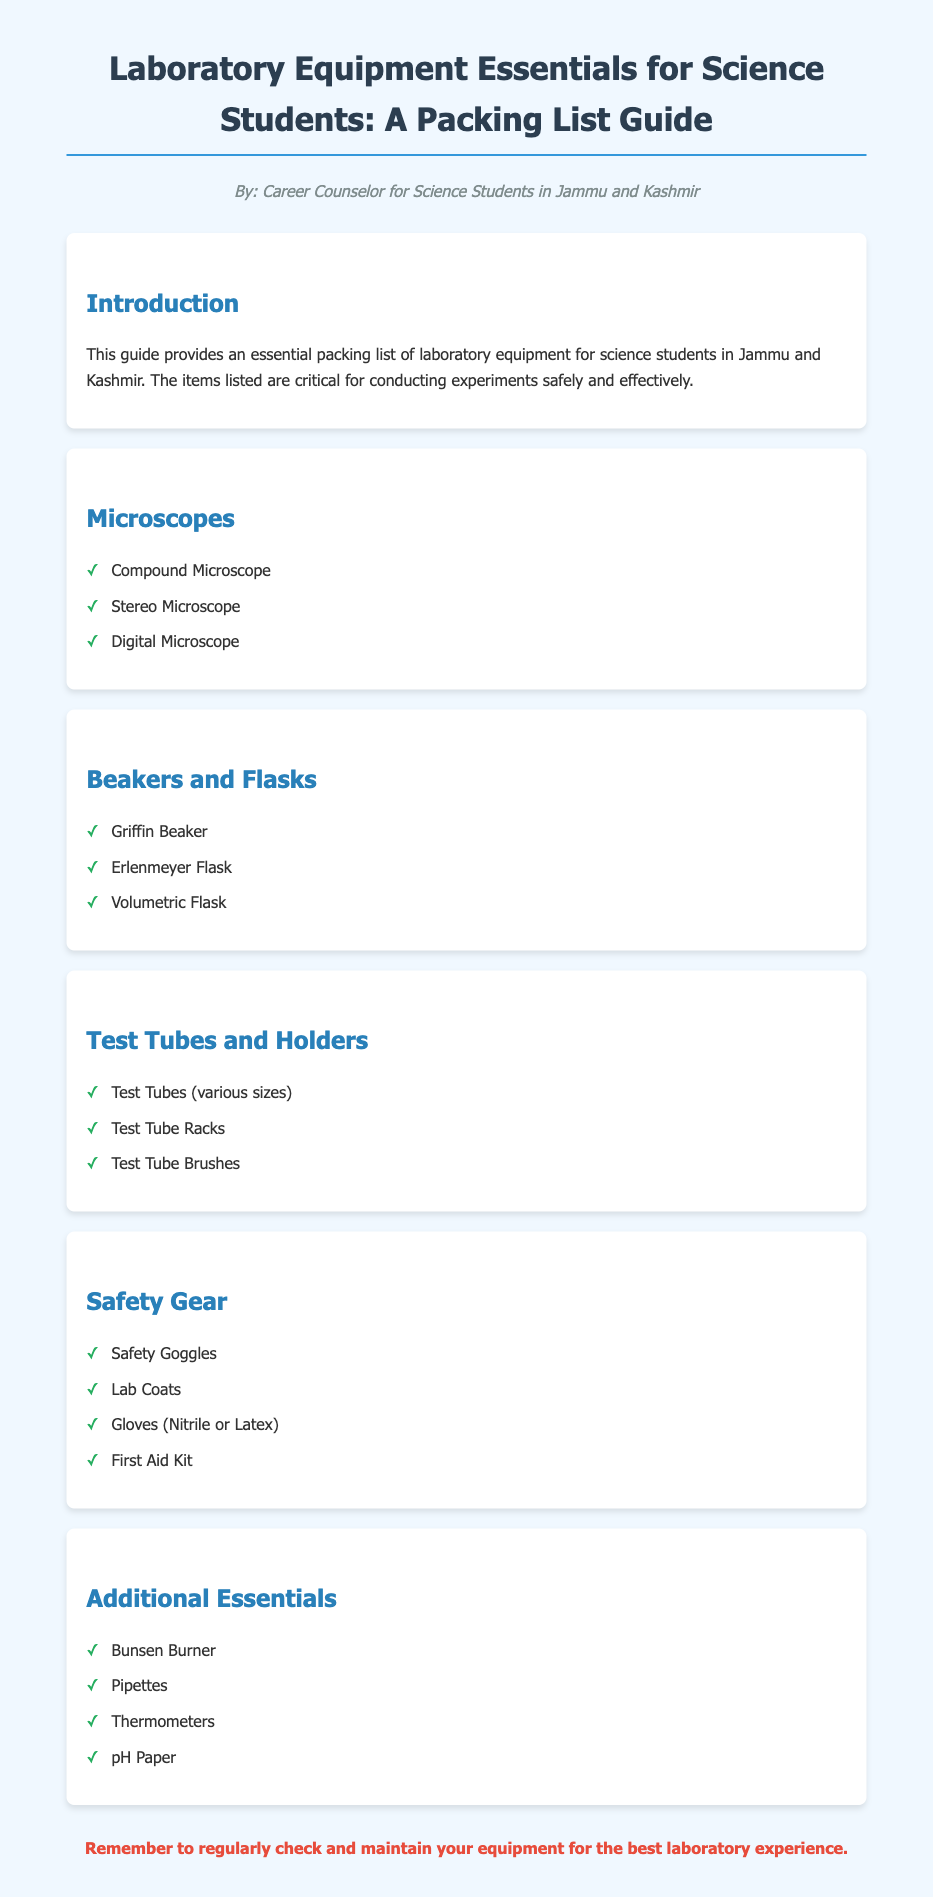What is the title of the document? The title is located at the beginning of the document, summarizing its content.
Answer: Laboratory Equipment Essentials for Science Students: A Packing List Guide How many types of microscopes are listed? The document specifies the types of microscopes under the "Microscopes" section.
Answer: Three What is one type of flask mentioned in the document? The document lists different types of flasks in the "Beakers and Flasks" section.
Answer: Erlenmeyer Flask What type of safety gear is included in the list? The "Safety Gear" section outlines various essential safety items for laboratory use.
Answer: Safety Goggles Which equipment is mentioned under "Additional Essentials"? This section includes various items that are important for experiments beyond the basic equipment.
Answer: Bunsen Burner What is the recommended action regarding equipment maintenance? The conclusion of the document suggests best practices for maintaining equipment.
Answer: Regularly check and maintain Name one item listed under Test Tubes and Holders. The "Test Tubes and Holders" section contains various items related to test tubes.
Answer: Test Tube Racks What is the color associated with the title text? The title’s color is specified in the styling section, relating to its visual presentation.
Answer: Dark blue 